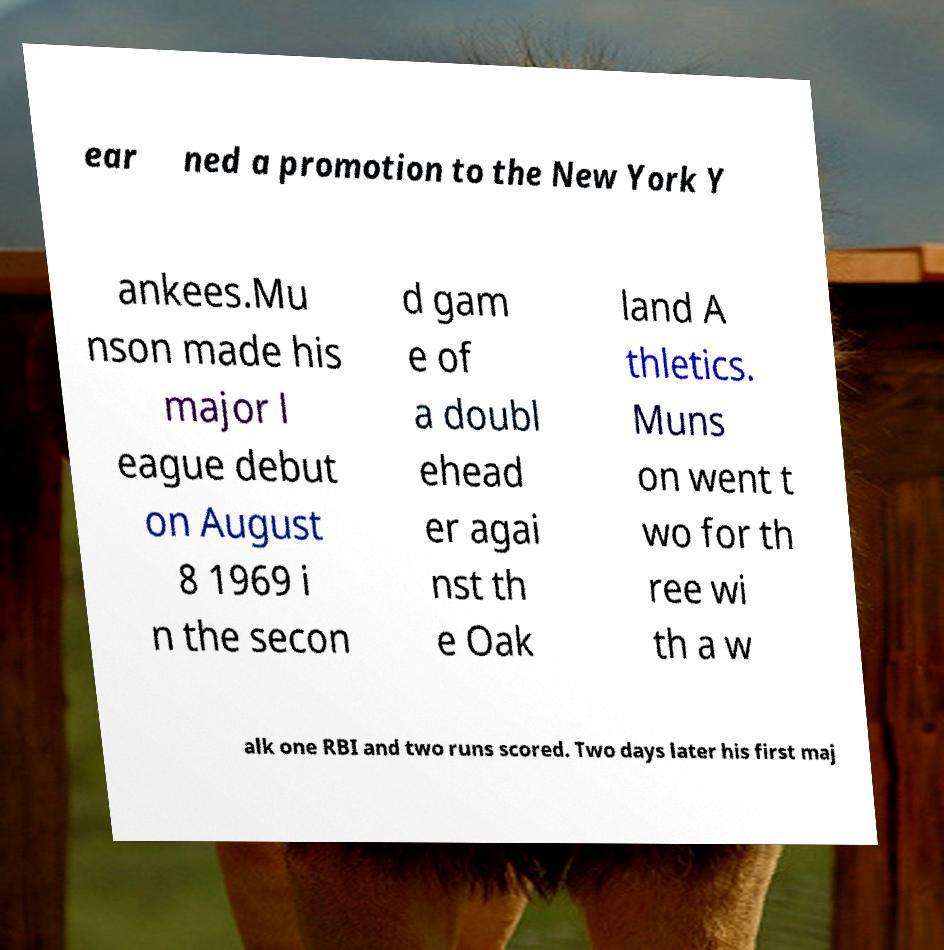For documentation purposes, I need the text within this image transcribed. Could you provide that? ear ned a promotion to the New York Y ankees.Mu nson made his major l eague debut on August 8 1969 i n the secon d gam e of a doubl ehead er agai nst th e Oak land A thletics. Muns on went t wo for th ree wi th a w alk one RBI and two runs scored. Two days later his first maj 